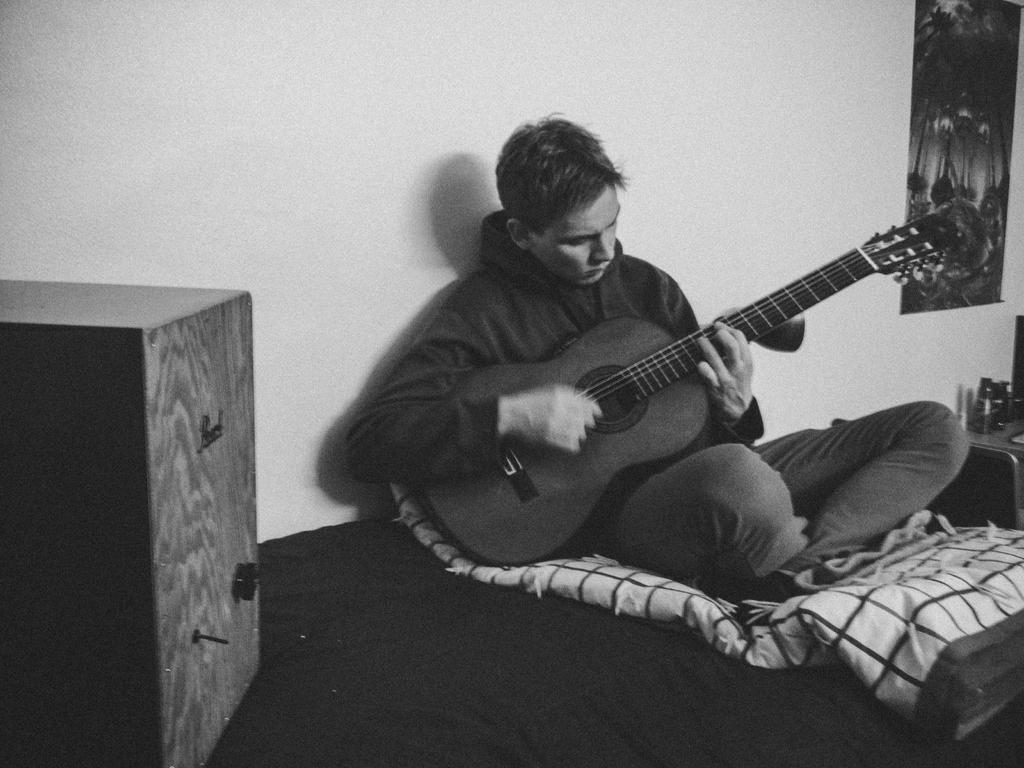In one or two sentences, can you explain what this image depicts? The image is inside the room. In the image we can see a man playing his guitar. On left of the man there is a box, the man is sitting on his bed. On bed we can see blankets, on right side of the man there is a painting,table. On table we can see a bottle,jar in background there is a white color wall. 